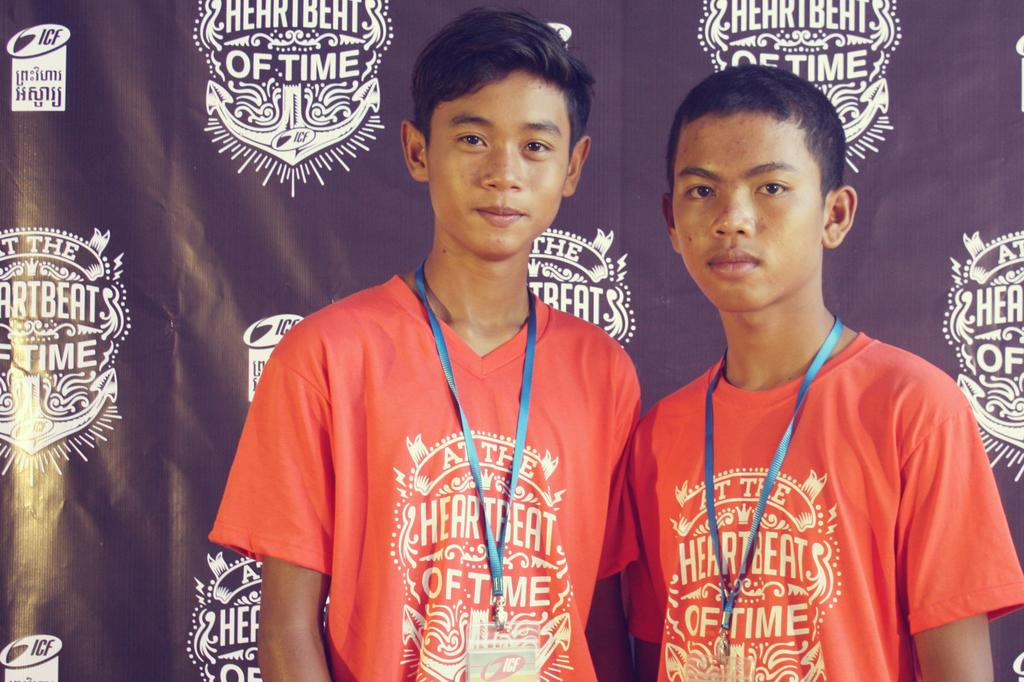<image>
Write a terse but informative summary of the picture. two boys side by side with the word time on their shirts 